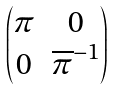<formula> <loc_0><loc_0><loc_500><loc_500>\begin{pmatrix} \pi & 0 \\ 0 & \overline { \pi } ^ { - 1 } \end{pmatrix}</formula> 